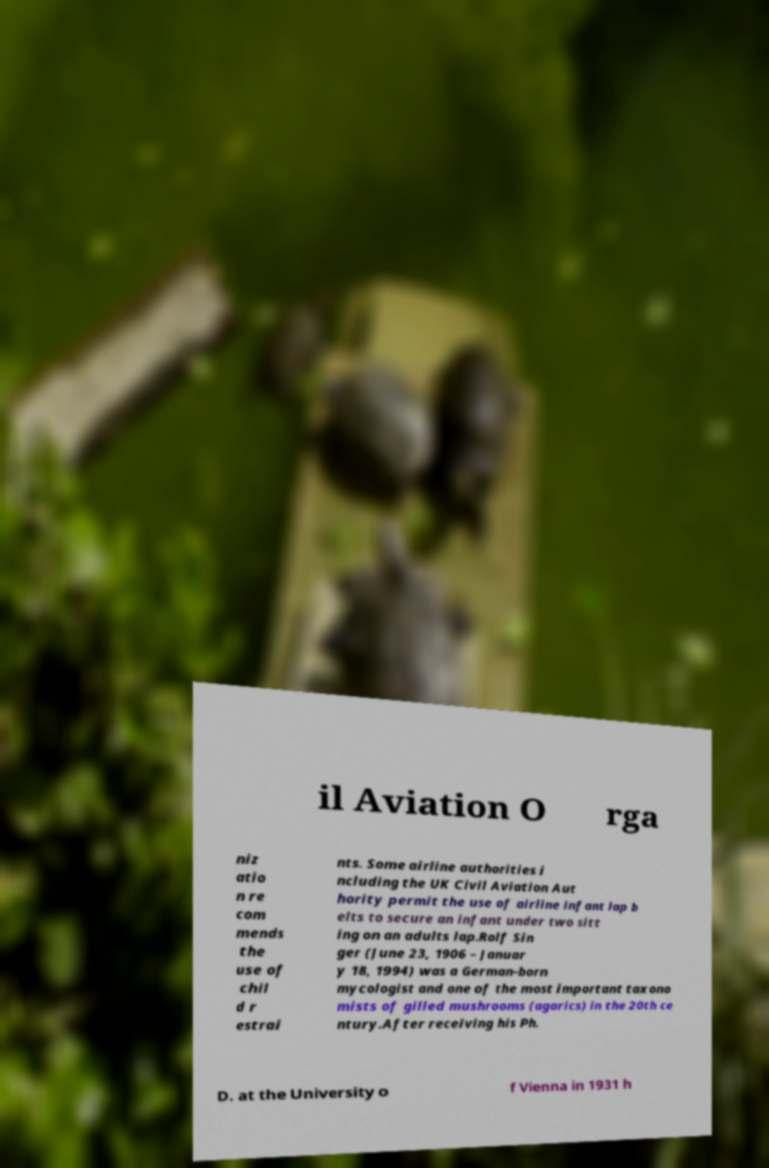What messages or text are displayed in this image? I need them in a readable, typed format. il Aviation O rga niz atio n re com mends the use of chil d r estrai nts. Some airline authorities i ncluding the UK Civil Aviation Aut hority permit the use of airline infant lap b elts to secure an infant under two sitt ing on an adults lap.Rolf Sin ger (June 23, 1906 – Januar y 18, 1994) was a German-born mycologist and one of the most important taxono mists of gilled mushrooms (agarics) in the 20th ce ntury.After receiving his Ph. D. at the University o f Vienna in 1931 h 